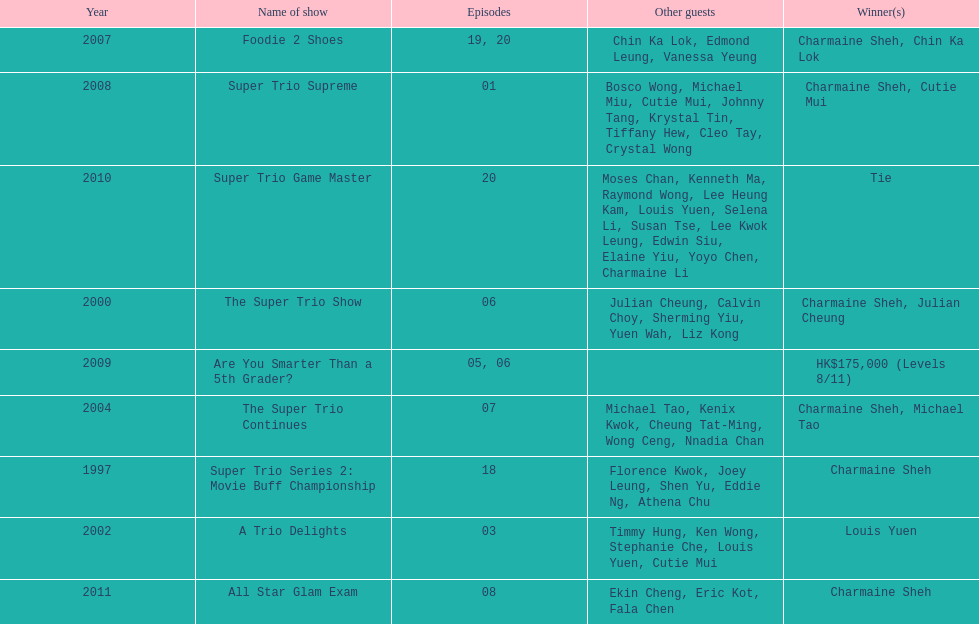How many episodes was charmaine sheh on in the variety show super trio 2: movie buff champions 18. 